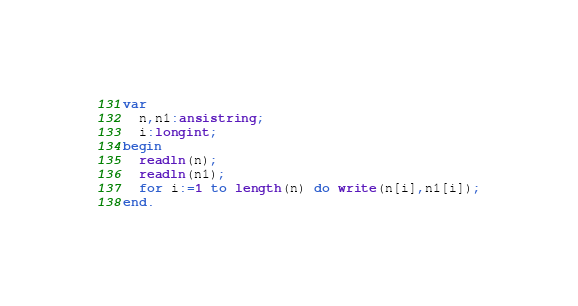Convert code to text. <code><loc_0><loc_0><loc_500><loc_500><_Pascal_>var
  n,n1:ansistring;
  i:longint;
begin
  readln(n);
  readln(n1);
  for i:=1 to length(n) do write(n[i],n1[i]);
end.</code> 